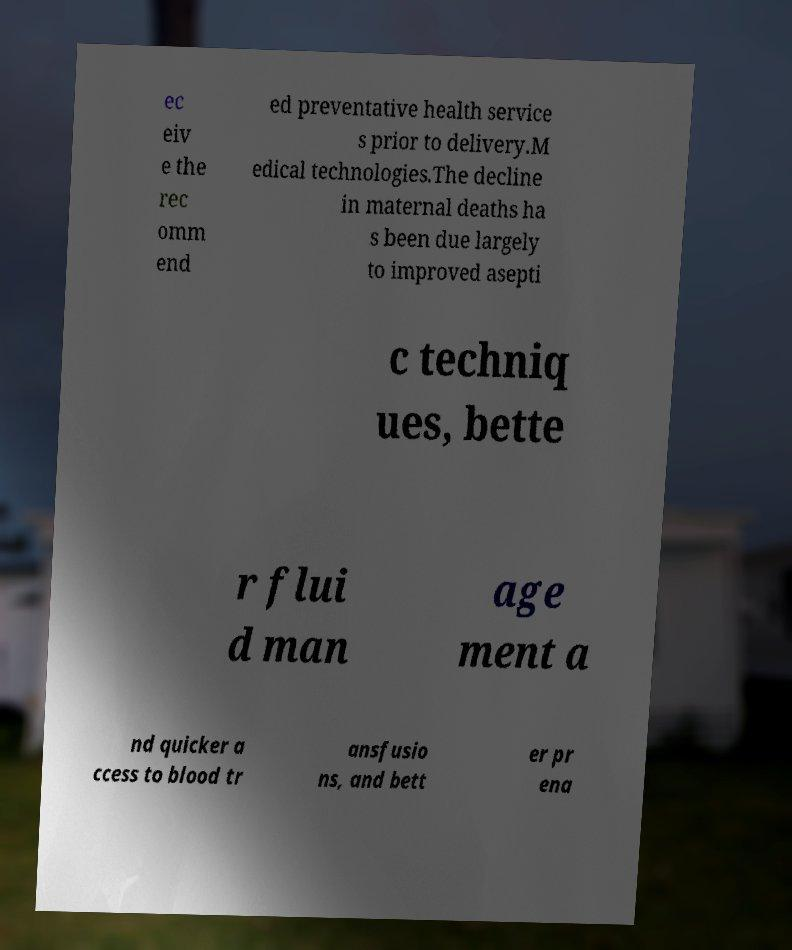Please read and relay the text visible in this image. What does it say? ec eiv e the rec omm end ed preventative health service s prior to delivery.M edical technologies.The decline in maternal deaths ha s been due largely to improved asepti c techniq ues, bette r flui d man age ment a nd quicker a ccess to blood tr ansfusio ns, and bett er pr ena 